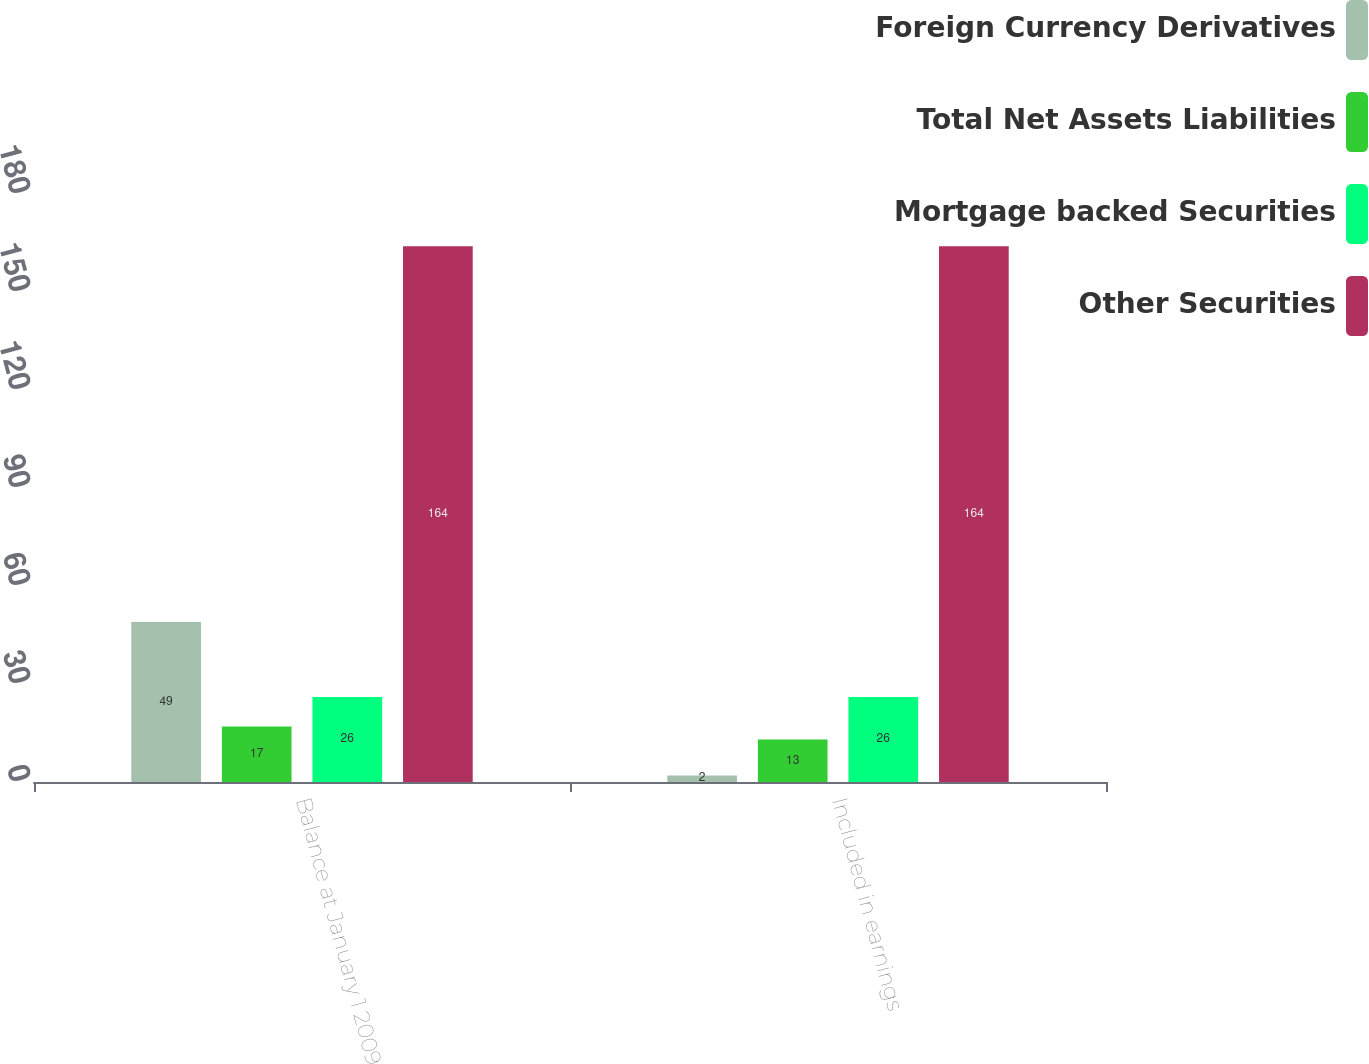<chart> <loc_0><loc_0><loc_500><loc_500><stacked_bar_chart><ecel><fcel>Balance at January 1 2009<fcel>Included in earnings<nl><fcel>Foreign Currency Derivatives<fcel>49<fcel>2<nl><fcel>Total Net Assets Liabilities<fcel>17<fcel>13<nl><fcel>Mortgage backed Securities<fcel>26<fcel>26<nl><fcel>Other Securities<fcel>164<fcel>164<nl></chart> 